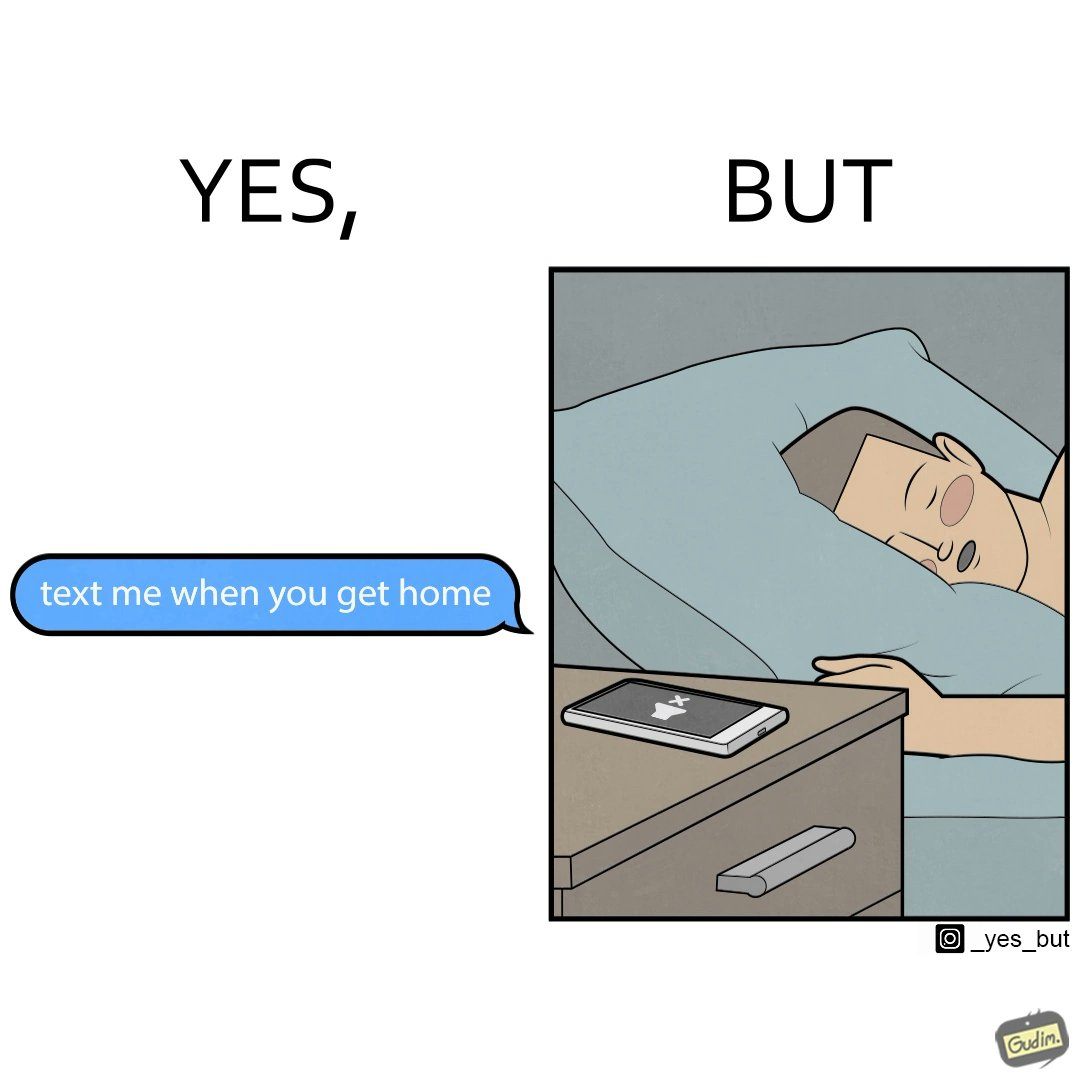Is this a satirical image? Yes, this image is satirical. 